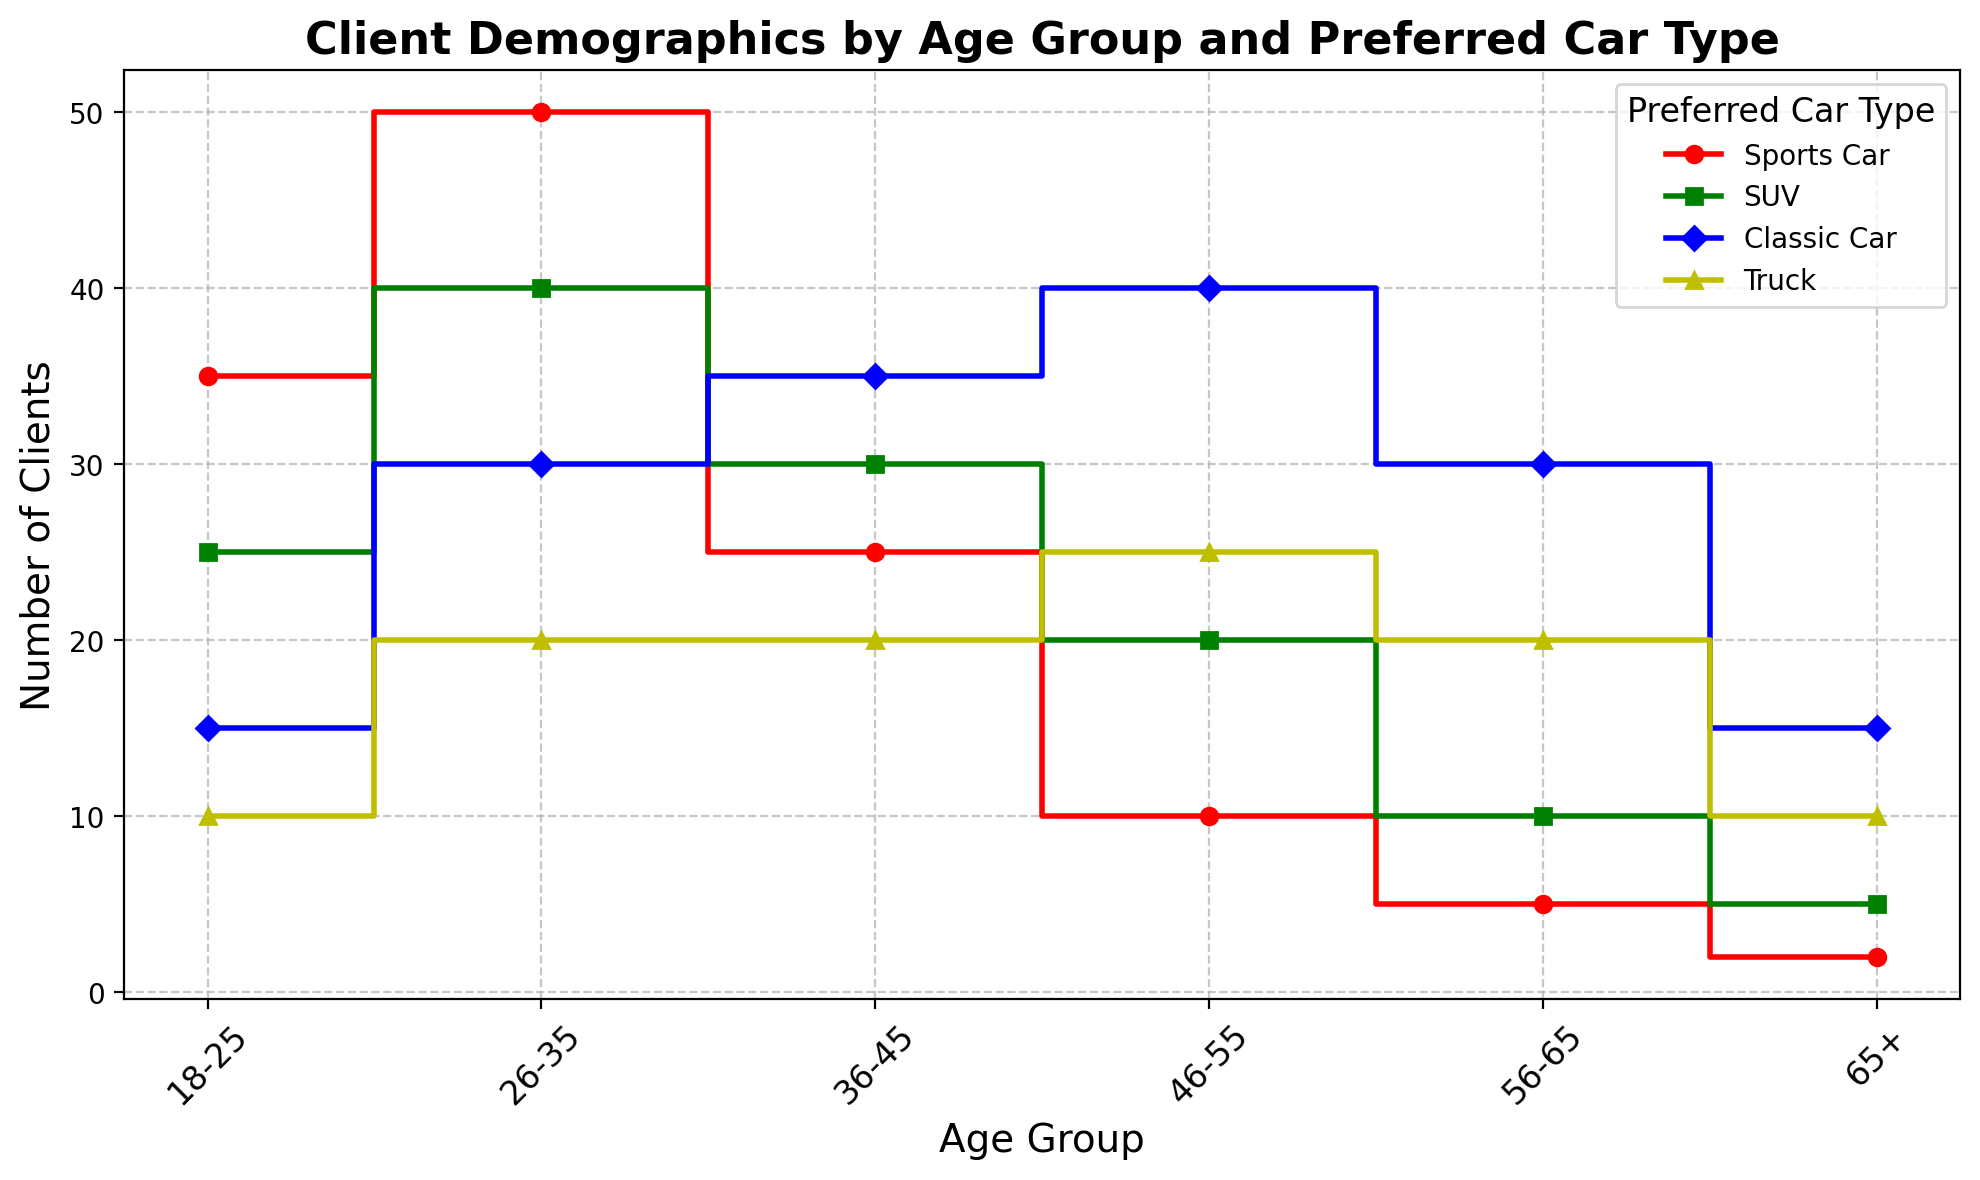Which age group has the highest number of clients who prefer sports cars? The age group bars or markers of the different preferred car types can be seen on the x-axis, and sports car data points are marked in red with 'o'. By observing the height of these markers, the highest number is at '26-35'.
Answer: 26-35 How many total clients prefer SUVs across all age groups? The number of clients preferring SUVs can be summed across all age groups: 25 (18-25) + 40 (26-35) + 30 (36-45) + 20 (46-55) + 10 (56-65) + 5 (65+): 25 + 40 + 30 + 20 + 10 + 5 = 130.
Answer: 130 Which preferred car type has the least number of clients in the 65+ age group? Checking the vertical heights of markers for the 65+ age group, it is clear that the red (sports car) marker is at its lowest at 2 clients.
Answer: Sports Car What is the difference in the number of clients preferring trucks between the 26-35 and 46-55 age groups? Observing the yellow (truck) markers, the 26-35 age group has 20 clients, and the 46-55 has 25. The difference is calculated as 25 - 20 = 5.
Answer: 5 How does the number of clients preferring classic cars compare between the 36-45 and 46-55 age groups? Looking at the blue (classic car) markers, the 36-45 age group has 35 clients, and 46-55 has 40 clients. The latter is higher by a difference of 40 - 35 = 5.
Answer: The 46-55 age group has 5 more clients In which age group is the lowest number of clients for trucks observed? Yellow (truck) markers for all age groups show the lowest height in the 18-25 age group at 10.
Answer: 18-25 What is the combined total number of clients for classic cars in the 26-35 and 36-45 age groups? Sum of the clients for classic cars in these age groups is 30 (26-35) + 35 (36-45) = 65.
Answer: 65 Which age group has the most equal distribution among the four types of cars? The differences between the heights of the markers across one age group would indicate an equal distribution. The 36-45 age group's numbers (25, 30, 35, 20) are closest.
Answer: 36-45 